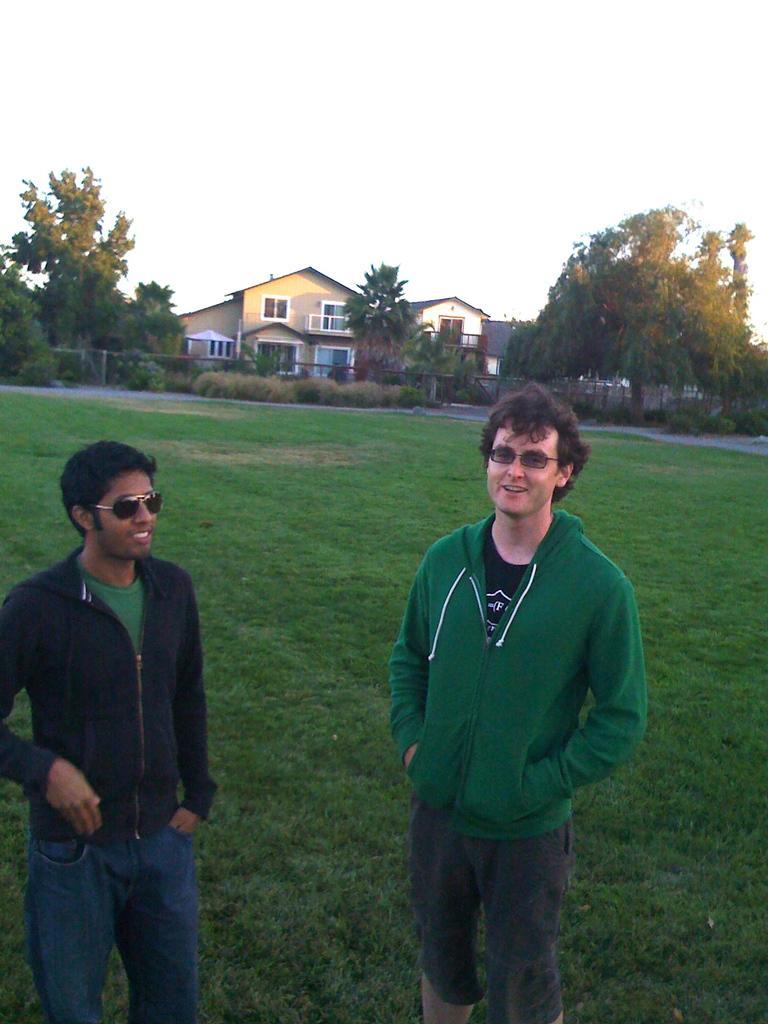Please provide a concise description of this image. There are two persons wearing goggles and standing. In the back there is grass lawn, trees, buildings with windows and sky. 